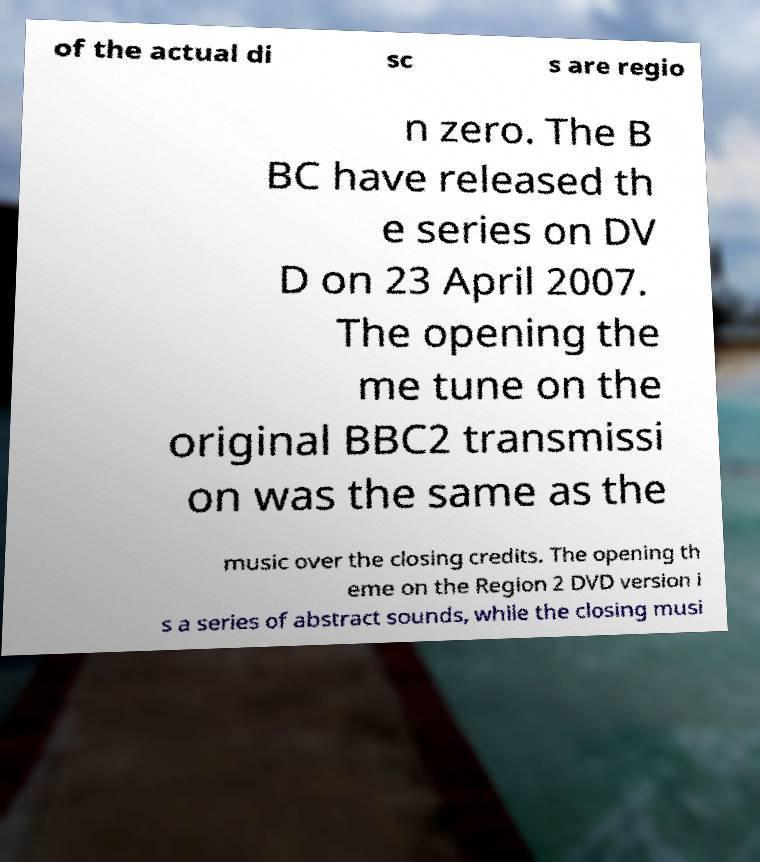There's text embedded in this image that I need extracted. Can you transcribe it verbatim? of the actual di sc s are regio n zero. The B BC have released th e series on DV D on 23 April 2007. The opening the me tune on the original BBC2 transmissi on was the same as the music over the closing credits. The opening th eme on the Region 2 DVD version i s a series of abstract sounds, while the closing musi 